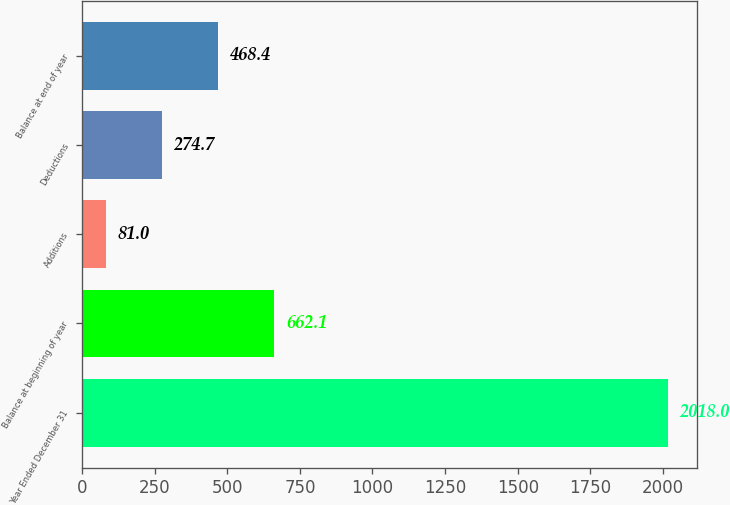Convert chart to OTSL. <chart><loc_0><loc_0><loc_500><loc_500><bar_chart><fcel>Year Ended December 31<fcel>Balance at beginning of year<fcel>Additions<fcel>Deductions<fcel>Balance at end of year<nl><fcel>2018<fcel>662.1<fcel>81<fcel>274.7<fcel>468.4<nl></chart> 